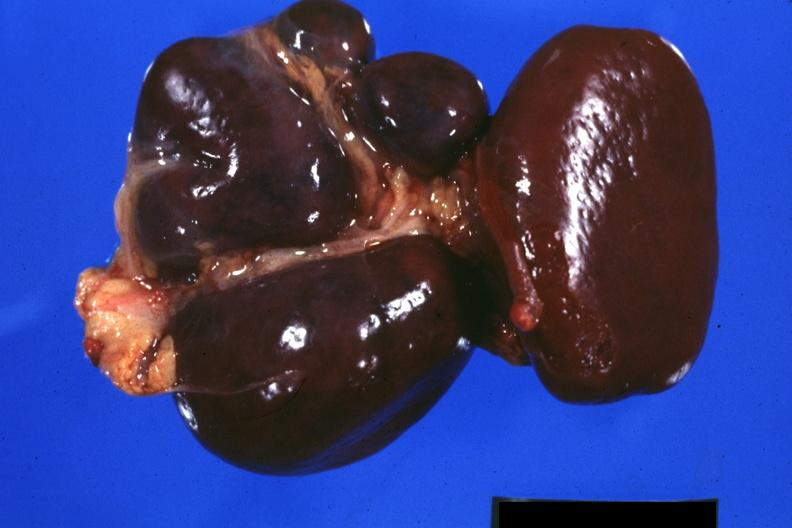s spleen present?
Answer the question using a single word or phrase. Yes 